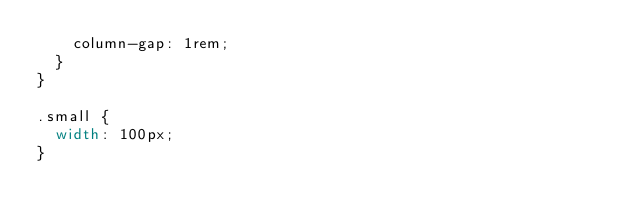Convert code to text. <code><loc_0><loc_0><loc_500><loc_500><_CSS_>    column-gap: 1rem;
  }
}

.small {
  width: 100px;
}
</code> 